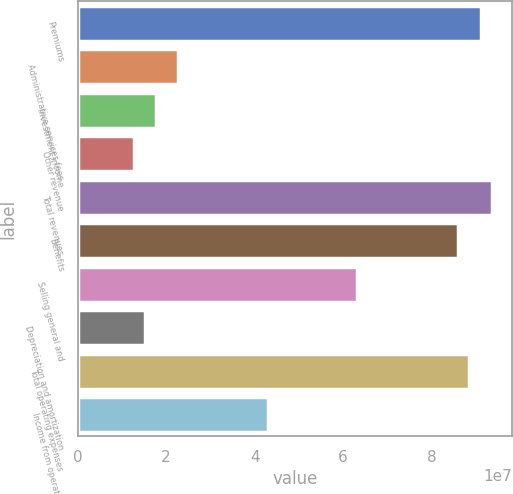Convert chart. <chart><loc_0><loc_0><loc_500><loc_500><bar_chart><fcel>Premiums<fcel>Administrative services fees<fcel>Investment income<fcel>Other revenue<fcel>Total revenues<fcel>Benefits<fcel>Selling general and<fcel>Depreciation and amortization<fcel>Total operating expenses<fcel>Income from operations<nl><fcel>9.10439e+07<fcel>2.2761e+07<fcel>1.7703e+07<fcel>1.2645e+07<fcel>9.35729e+07<fcel>8.5986e+07<fcel>6.3225e+07<fcel>1.5174e+07<fcel>8.85149e+07<fcel>4.2993e+07<nl></chart> 